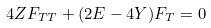Convert formula to latex. <formula><loc_0><loc_0><loc_500><loc_500>4 Z F _ { T T } + ( 2 E - 4 Y ) F _ { T } = 0</formula> 